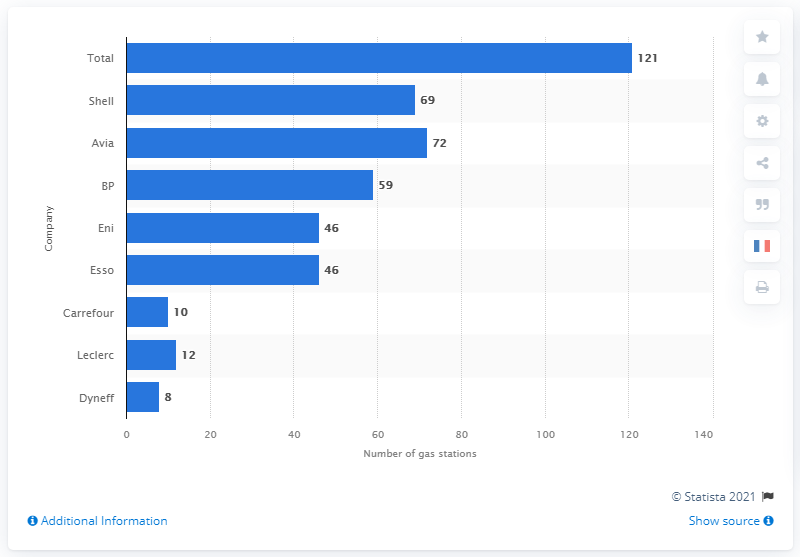Draw attention to some important aspects in this diagram. In 2018, Esso operated 46 gas stations on French motorways and expressways. 